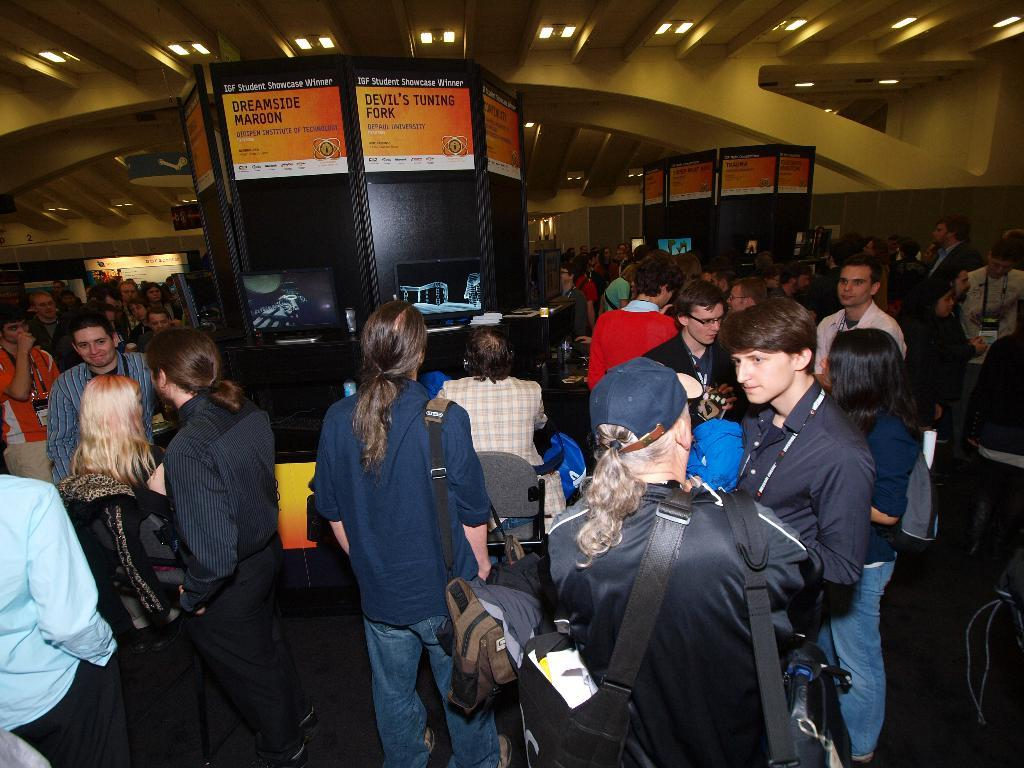What is the main subject in the center of the image? There are people in the center of the image. What can be seen at the top of the image? There is a ceiling with lights at the top of the image. What is on the right side of the image? There is a wall on the right side of the image. What type of soup is being served in the image? There is no soup present in the image. What game are the people playing in the image? There is no game being played in the image; the people are simply present in the center. 